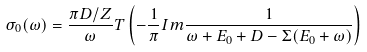<formula> <loc_0><loc_0><loc_500><loc_500>\sigma _ { 0 } ( \omega ) = \frac { \pi D / Z } { \omega } T \left ( - \frac { 1 } { \pi } I m \frac { 1 } { \omega + E _ { 0 } + D - \Sigma ( E _ { 0 } + \omega ) } \right )</formula> 